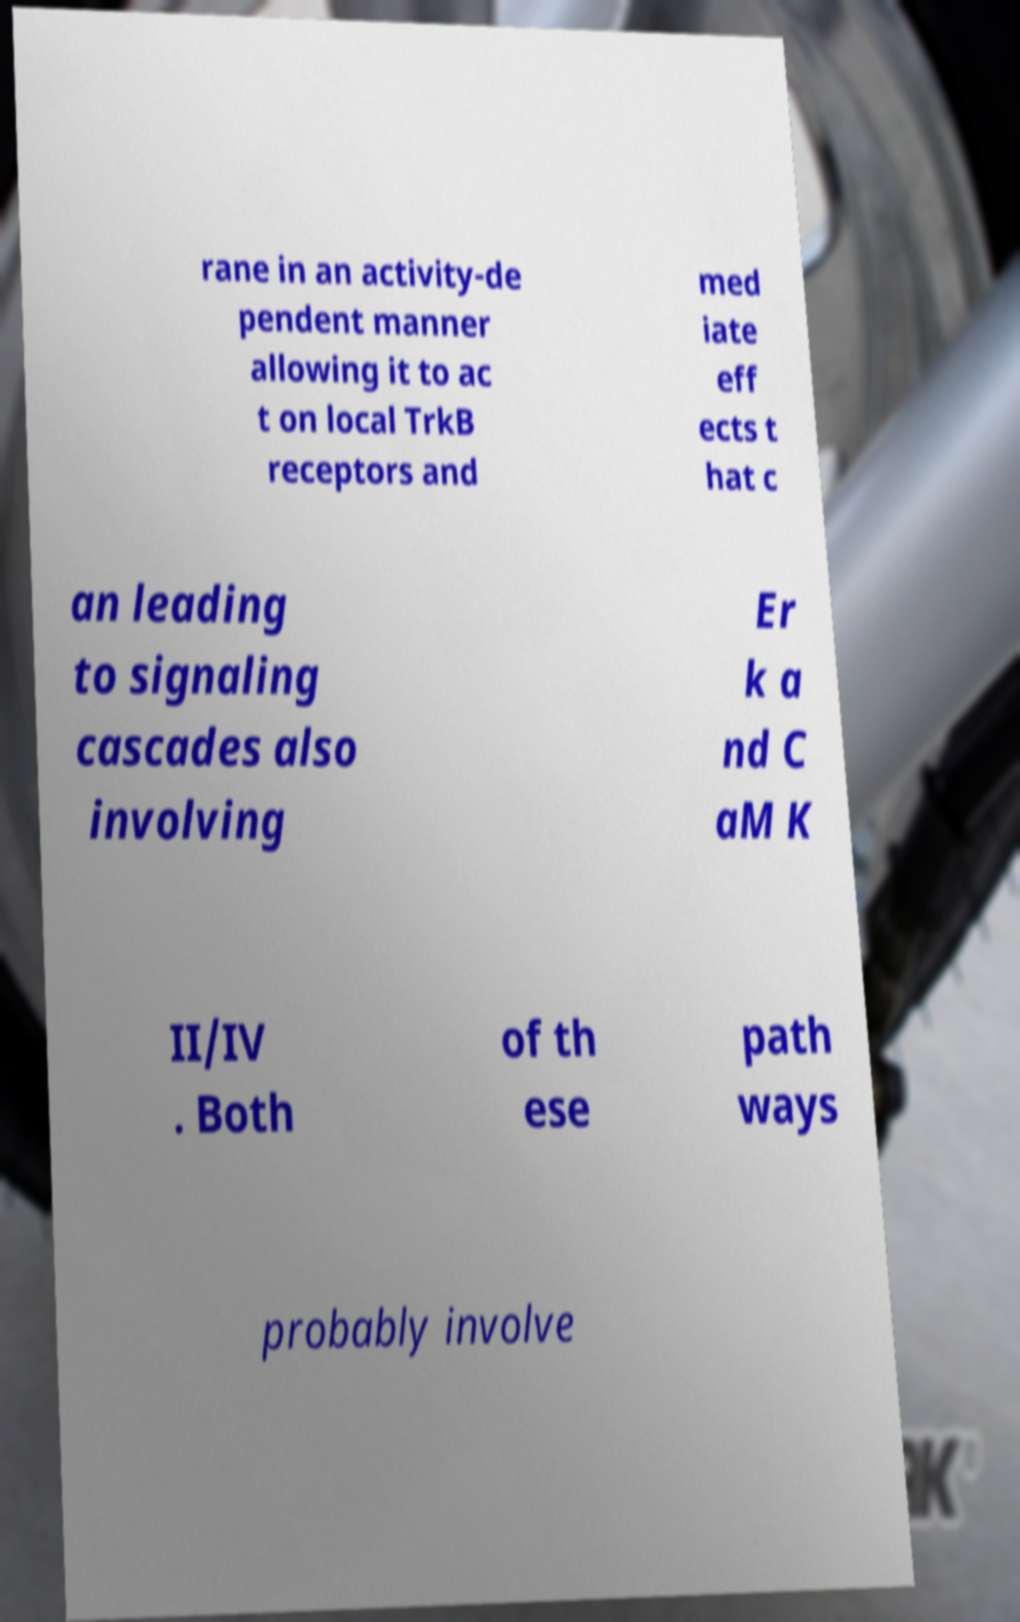Please identify and transcribe the text found in this image. rane in an activity-de pendent manner allowing it to ac t on local TrkB receptors and med iate eff ects t hat c an leading to signaling cascades also involving Er k a nd C aM K II/IV . Both of th ese path ways probably involve 